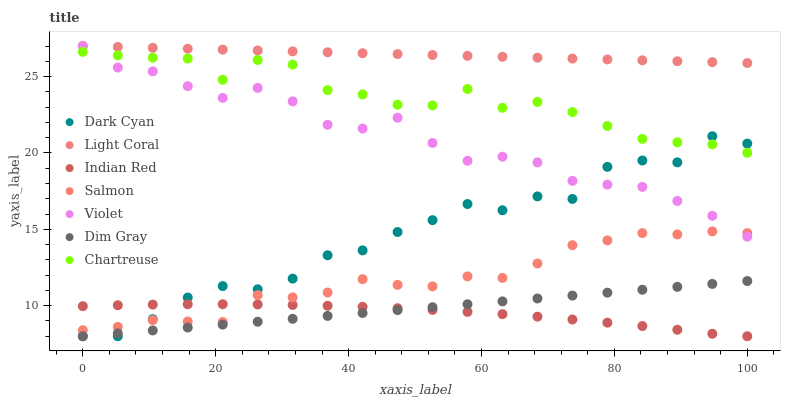Does Indian Red have the minimum area under the curve?
Answer yes or no. Yes. Does Light Coral have the maximum area under the curve?
Answer yes or no. Yes. Does Salmon have the minimum area under the curve?
Answer yes or no. No. Does Salmon have the maximum area under the curve?
Answer yes or no. No. Is Dim Gray the smoothest?
Answer yes or no. Yes. Is Dark Cyan the roughest?
Answer yes or no. Yes. Is Salmon the smoothest?
Answer yes or no. No. Is Salmon the roughest?
Answer yes or no. No. Does Dim Gray have the lowest value?
Answer yes or no. Yes. Does Salmon have the lowest value?
Answer yes or no. No. Does Violet have the highest value?
Answer yes or no. Yes. Does Salmon have the highest value?
Answer yes or no. No. Is Dim Gray less than Salmon?
Answer yes or no. Yes. Is Chartreuse greater than Indian Red?
Answer yes or no. Yes. Does Dark Cyan intersect Violet?
Answer yes or no. Yes. Is Dark Cyan less than Violet?
Answer yes or no. No. Is Dark Cyan greater than Violet?
Answer yes or no. No. Does Dim Gray intersect Salmon?
Answer yes or no. No. 